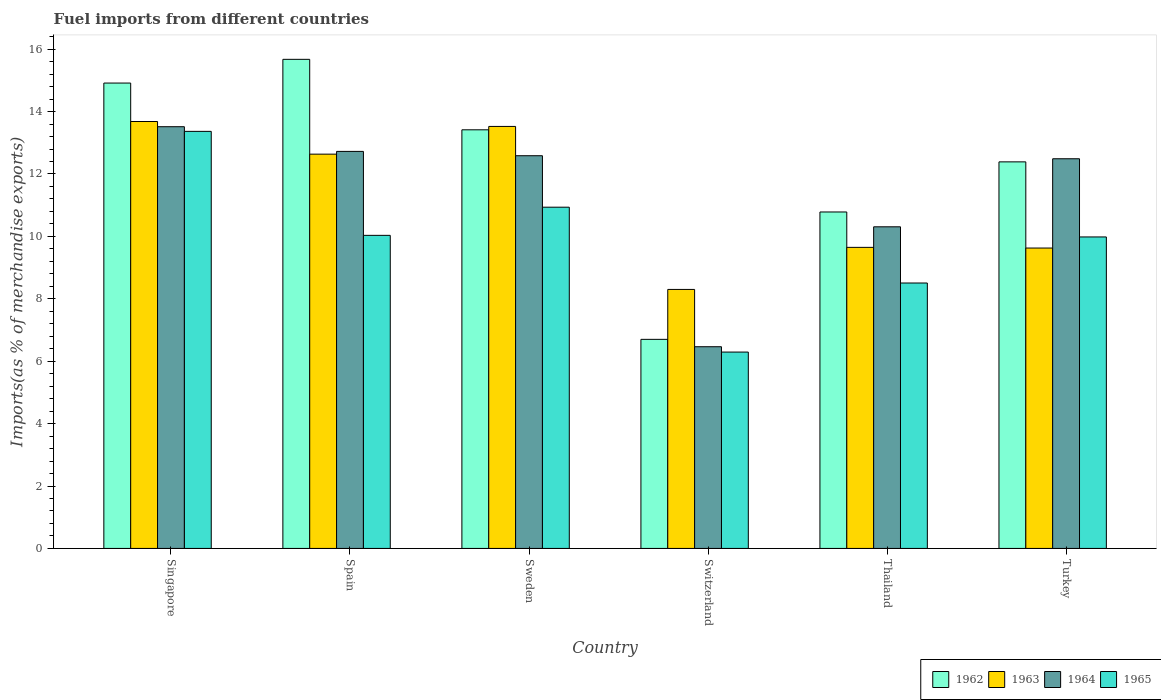How many different coloured bars are there?
Give a very brief answer. 4. Are the number of bars on each tick of the X-axis equal?
Give a very brief answer. Yes. How many bars are there on the 2nd tick from the left?
Provide a succinct answer. 4. What is the percentage of imports to different countries in 1962 in Switzerland?
Offer a terse response. 6.7. Across all countries, what is the maximum percentage of imports to different countries in 1965?
Your answer should be compact. 13.37. Across all countries, what is the minimum percentage of imports to different countries in 1965?
Ensure brevity in your answer.  6.29. In which country was the percentage of imports to different countries in 1962 maximum?
Ensure brevity in your answer.  Spain. In which country was the percentage of imports to different countries in 1962 minimum?
Provide a succinct answer. Switzerland. What is the total percentage of imports to different countries in 1964 in the graph?
Your response must be concise. 68.08. What is the difference between the percentage of imports to different countries in 1963 in Thailand and that in Turkey?
Provide a short and direct response. 0.02. What is the difference between the percentage of imports to different countries in 1964 in Turkey and the percentage of imports to different countries in 1963 in Switzerland?
Offer a very short reply. 4.19. What is the average percentage of imports to different countries in 1962 per country?
Make the answer very short. 12.31. What is the difference between the percentage of imports to different countries of/in 1963 and percentage of imports to different countries of/in 1964 in Singapore?
Give a very brief answer. 0.17. What is the ratio of the percentage of imports to different countries in 1965 in Singapore to that in Thailand?
Keep it short and to the point. 1.57. Is the percentage of imports to different countries in 1965 in Spain less than that in Sweden?
Provide a succinct answer. Yes. What is the difference between the highest and the second highest percentage of imports to different countries in 1963?
Your response must be concise. 0.89. What is the difference between the highest and the lowest percentage of imports to different countries in 1964?
Your answer should be very brief. 7.05. In how many countries, is the percentage of imports to different countries in 1963 greater than the average percentage of imports to different countries in 1963 taken over all countries?
Your response must be concise. 3. What does the 3rd bar from the left in Singapore represents?
Make the answer very short. 1964. What does the 2nd bar from the right in Switzerland represents?
Your response must be concise. 1964. Where does the legend appear in the graph?
Give a very brief answer. Bottom right. How many legend labels are there?
Make the answer very short. 4. How are the legend labels stacked?
Make the answer very short. Horizontal. What is the title of the graph?
Keep it short and to the point. Fuel imports from different countries. Does "2002" appear as one of the legend labels in the graph?
Provide a succinct answer. No. What is the label or title of the Y-axis?
Your answer should be compact. Imports(as % of merchandise exports). What is the Imports(as % of merchandise exports) in 1962 in Singapore?
Offer a terse response. 14.91. What is the Imports(as % of merchandise exports) in 1963 in Singapore?
Keep it short and to the point. 13.68. What is the Imports(as % of merchandise exports) in 1964 in Singapore?
Ensure brevity in your answer.  13.51. What is the Imports(as % of merchandise exports) in 1965 in Singapore?
Your answer should be very brief. 13.37. What is the Imports(as % of merchandise exports) of 1962 in Spain?
Make the answer very short. 15.67. What is the Imports(as % of merchandise exports) of 1963 in Spain?
Provide a short and direct response. 12.64. What is the Imports(as % of merchandise exports) of 1964 in Spain?
Make the answer very short. 12.72. What is the Imports(as % of merchandise exports) in 1965 in Spain?
Your answer should be very brief. 10.03. What is the Imports(as % of merchandise exports) in 1962 in Sweden?
Your response must be concise. 13.42. What is the Imports(as % of merchandise exports) of 1963 in Sweden?
Keep it short and to the point. 13.52. What is the Imports(as % of merchandise exports) in 1964 in Sweden?
Provide a succinct answer. 12.58. What is the Imports(as % of merchandise exports) in 1965 in Sweden?
Your response must be concise. 10.93. What is the Imports(as % of merchandise exports) of 1962 in Switzerland?
Make the answer very short. 6.7. What is the Imports(as % of merchandise exports) of 1963 in Switzerland?
Provide a short and direct response. 8.3. What is the Imports(as % of merchandise exports) in 1964 in Switzerland?
Offer a terse response. 6.46. What is the Imports(as % of merchandise exports) in 1965 in Switzerland?
Offer a very short reply. 6.29. What is the Imports(as % of merchandise exports) in 1962 in Thailand?
Keep it short and to the point. 10.78. What is the Imports(as % of merchandise exports) in 1963 in Thailand?
Make the answer very short. 9.65. What is the Imports(as % of merchandise exports) of 1964 in Thailand?
Offer a very short reply. 10.31. What is the Imports(as % of merchandise exports) in 1965 in Thailand?
Ensure brevity in your answer.  8.51. What is the Imports(as % of merchandise exports) of 1962 in Turkey?
Provide a short and direct response. 12.39. What is the Imports(as % of merchandise exports) of 1963 in Turkey?
Provide a short and direct response. 9.63. What is the Imports(as % of merchandise exports) of 1964 in Turkey?
Your answer should be compact. 12.49. What is the Imports(as % of merchandise exports) in 1965 in Turkey?
Offer a terse response. 9.98. Across all countries, what is the maximum Imports(as % of merchandise exports) in 1962?
Offer a very short reply. 15.67. Across all countries, what is the maximum Imports(as % of merchandise exports) in 1963?
Keep it short and to the point. 13.68. Across all countries, what is the maximum Imports(as % of merchandise exports) in 1964?
Keep it short and to the point. 13.51. Across all countries, what is the maximum Imports(as % of merchandise exports) in 1965?
Ensure brevity in your answer.  13.37. Across all countries, what is the minimum Imports(as % of merchandise exports) of 1962?
Make the answer very short. 6.7. Across all countries, what is the minimum Imports(as % of merchandise exports) in 1963?
Your answer should be very brief. 8.3. Across all countries, what is the minimum Imports(as % of merchandise exports) of 1964?
Give a very brief answer. 6.46. Across all countries, what is the minimum Imports(as % of merchandise exports) of 1965?
Your response must be concise. 6.29. What is the total Imports(as % of merchandise exports) in 1962 in the graph?
Your response must be concise. 73.87. What is the total Imports(as % of merchandise exports) in 1963 in the graph?
Your response must be concise. 67.41. What is the total Imports(as % of merchandise exports) of 1964 in the graph?
Provide a short and direct response. 68.08. What is the total Imports(as % of merchandise exports) in 1965 in the graph?
Your response must be concise. 59.11. What is the difference between the Imports(as % of merchandise exports) in 1962 in Singapore and that in Spain?
Provide a short and direct response. -0.76. What is the difference between the Imports(as % of merchandise exports) of 1963 in Singapore and that in Spain?
Offer a terse response. 1.05. What is the difference between the Imports(as % of merchandise exports) of 1964 in Singapore and that in Spain?
Give a very brief answer. 0.79. What is the difference between the Imports(as % of merchandise exports) of 1965 in Singapore and that in Spain?
Provide a succinct answer. 3.33. What is the difference between the Imports(as % of merchandise exports) in 1962 in Singapore and that in Sweden?
Offer a terse response. 1.5. What is the difference between the Imports(as % of merchandise exports) of 1963 in Singapore and that in Sweden?
Your response must be concise. 0.16. What is the difference between the Imports(as % of merchandise exports) in 1964 in Singapore and that in Sweden?
Ensure brevity in your answer.  0.93. What is the difference between the Imports(as % of merchandise exports) of 1965 in Singapore and that in Sweden?
Give a very brief answer. 2.43. What is the difference between the Imports(as % of merchandise exports) of 1962 in Singapore and that in Switzerland?
Your answer should be very brief. 8.21. What is the difference between the Imports(as % of merchandise exports) in 1963 in Singapore and that in Switzerland?
Make the answer very short. 5.38. What is the difference between the Imports(as % of merchandise exports) in 1964 in Singapore and that in Switzerland?
Your response must be concise. 7.05. What is the difference between the Imports(as % of merchandise exports) in 1965 in Singapore and that in Switzerland?
Give a very brief answer. 7.07. What is the difference between the Imports(as % of merchandise exports) in 1962 in Singapore and that in Thailand?
Give a very brief answer. 4.13. What is the difference between the Imports(as % of merchandise exports) of 1963 in Singapore and that in Thailand?
Provide a succinct answer. 4.03. What is the difference between the Imports(as % of merchandise exports) of 1964 in Singapore and that in Thailand?
Provide a succinct answer. 3.21. What is the difference between the Imports(as % of merchandise exports) of 1965 in Singapore and that in Thailand?
Make the answer very short. 4.86. What is the difference between the Imports(as % of merchandise exports) in 1962 in Singapore and that in Turkey?
Offer a terse response. 2.53. What is the difference between the Imports(as % of merchandise exports) of 1963 in Singapore and that in Turkey?
Offer a terse response. 4.05. What is the difference between the Imports(as % of merchandise exports) of 1964 in Singapore and that in Turkey?
Provide a succinct answer. 1.03. What is the difference between the Imports(as % of merchandise exports) of 1965 in Singapore and that in Turkey?
Keep it short and to the point. 3.38. What is the difference between the Imports(as % of merchandise exports) in 1962 in Spain and that in Sweden?
Offer a terse response. 2.26. What is the difference between the Imports(as % of merchandise exports) of 1963 in Spain and that in Sweden?
Provide a succinct answer. -0.89. What is the difference between the Imports(as % of merchandise exports) of 1964 in Spain and that in Sweden?
Your answer should be compact. 0.14. What is the difference between the Imports(as % of merchandise exports) of 1965 in Spain and that in Sweden?
Make the answer very short. -0.9. What is the difference between the Imports(as % of merchandise exports) in 1962 in Spain and that in Switzerland?
Make the answer very short. 8.97. What is the difference between the Imports(as % of merchandise exports) in 1963 in Spain and that in Switzerland?
Offer a terse response. 4.34. What is the difference between the Imports(as % of merchandise exports) of 1964 in Spain and that in Switzerland?
Provide a succinct answer. 6.26. What is the difference between the Imports(as % of merchandise exports) of 1965 in Spain and that in Switzerland?
Ensure brevity in your answer.  3.74. What is the difference between the Imports(as % of merchandise exports) of 1962 in Spain and that in Thailand?
Make the answer very short. 4.89. What is the difference between the Imports(as % of merchandise exports) of 1963 in Spain and that in Thailand?
Your answer should be compact. 2.99. What is the difference between the Imports(as % of merchandise exports) in 1964 in Spain and that in Thailand?
Provide a succinct answer. 2.42. What is the difference between the Imports(as % of merchandise exports) of 1965 in Spain and that in Thailand?
Give a very brief answer. 1.53. What is the difference between the Imports(as % of merchandise exports) in 1962 in Spain and that in Turkey?
Ensure brevity in your answer.  3.29. What is the difference between the Imports(as % of merchandise exports) in 1963 in Spain and that in Turkey?
Your answer should be compact. 3.01. What is the difference between the Imports(as % of merchandise exports) in 1964 in Spain and that in Turkey?
Offer a terse response. 0.24. What is the difference between the Imports(as % of merchandise exports) of 1965 in Spain and that in Turkey?
Ensure brevity in your answer.  0.05. What is the difference between the Imports(as % of merchandise exports) of 1962 in Sweden and that in Switzerland?
Provide a short and direct response. 6.72. What is the difference between the Imports(as % of merchandise exports) of 1963 in Sweden and that in Switzerland?
Ensure brevity in your answer.  5.22. What is the difference between the Imports(as % of merchandise exports) of 1964 in Sweden and that in Switzerland?
Offer a very short reply. 6.12. What is the difference between the Imports(as % of merchandise exports) in 1965 in Sweden and that in Switzerland?
Keep it short and to the point. 4.64. What is the difference between the Imports(as % of merchandise exports) in 1962 in Sweden and that in Thailand?
Your answer should be very brief. 2.63. What is the difference between the Imports(as % of merchandise exports) in 1963 in Sweden and that in Thailand?
Your response must be concise. 3.88. What is the difference between the Imports(as % of merchandise exports) in 1964 in Sweden and that in Thailand?
Make the answer very short. 2.28. What is the difference between the Imports(as % of merchandise exports) in 1965 in Sweden and that in Thailand?
Keep it short and to the point. 2.43. What is the difference between the Imports(as % of merchandise exports) of 1962 in Sweden and that in Turkey?
Give a very brief answer. 1.03. What is the difference between the Imports(as % of merchandise exports) of 1963 in Sweden and that in Turkey?
Your answer should be compact. 3.9. What is the difference between the Imports(as % of merchandise exports) of 1964 in Sweden and that in Turkey?
Give a very brief answer. 0.1. What is the difference between the Imports(as % of merchandise exports) of 1965 in Sweden and that in Turkey?
Make the answer very short. 0.95. What is the difference between the Imports(as % of merchandise exports) of 1962 in Switzerland and that in Thailand?
Keep it short and to the point. -4.08. What is the difference between the Imports(as % of merchandise exports) in 1963 in Switzerland and that in Thailand?
Give a very brief answer. -1.35. What is the difference between the Imports(as % of merchandise exports) in 1964 in Switzerland and that in Thailand?
Your answer should be compact. -3.84. What is the difference between the Imports(as % of merchandise exports) of 1965 in Switzerland and that in Thailand?
Keep it short and to the point. -2.21. What is the difference between the Imports(as % of merchandise exports) in 1962 in Switzerland and that in Turkey?
Your answer should be very brief. -5.69. What is the difference between the Imports(as % of merchandise exports) of 1963 in Switzerland and that in Turkey?
Your answer should be very brief. -1.33. What is the difference between the Imports(as % of merchandise exports) of 1964 in Switzerland and that in Turkey?
Your response must be concise. -6.02. What is the difference between the Imports(as % of merchandise exports) in 1965 in Switzerland and that in Turkey?
Offer a very short reply. -3.69. What is the difference between the Imports(as % of merchandise exports) in 1962 in Thailand and that in Turkey?
Give a very brief answer. -1.61. What is the difference between the Imports(as % of merchandise exports) in 1963 in Thailand and that in Turkey?
Keep it short and to the point. 0.02. What is the difference between the Imports(as % of merchandise exports) of 1964 in Thailand and that in Turkey?
Your answer should be very brief. -2.18. What is the difference between the Imports(as % of merchandise exports) in 1965 in Thailand and that in Turkey?
Provide a succinct answer. -1.48. What is the difference between the Imports(as % of merchandise exports) in 1962 in Singapore and the Imports(as % of merchandise exports) in 1963 in Spain?
Make the answer very short. 2.28. What is the difference between the Imports(as % of merchandise exports) in 1962 in Singapore and the Imports(as % of merchandise exports) in 1964 in Spain?
Your answer should be compact. 2.19. What is the difference between the Imports(as % of merchandise exports) in 1962 in Singapore and the Imports(as % of merchandise exports) in 1965 in Spain?
Make the answer very short. 4.88. What is the difference between the Imports(as % of merchandise exports) in 1963 in Singapore and the Imports(as % of merchandise exports) in 1964 in Spain?
Ensure brevity in your answer.  0.96. What is the difference between the Imports(as % of merchandise exports) in 1963 in Singapore and the Imports(as % of merchandise exports) in 1965 in Spain?
Your response must be concise. 3.65. What is the difference between the Imports(as % of merchandise exports) of 1964 in Singapore and the Imports(as % of merchandise exports) of 1965 in Spain?
Your response must be concise. 3.48. What is the difference between the Imports(as % of merchandise exports) of 1962 in Singapore and the Imports(as % of merchandise exports) of 1963 in Sweden?
Your answer should be compact. 1.39. What is the difference between the Imports(as % of merchandise exports) of 1962 in Singapore and the Imports(as % of merchandise exports) of 1964 in Sweden?
Your response must be concise. 2.33. What is the difference between the Imports(as % of merchandise exports) in 1962 in Singapore and the Imports(as % of merchandise exports) in 1965 in Sweden?
Your answer should be compact. 3.98. What is the difference between the Imports(as % of merchandise exports) of 1963 in Singapore and the Imports(as % of merchandise exports) of 1964 in Sweden?
Your response must be concise. 1.1. What is the difference between the Imports(as % of merchandise exports) of 1963 in Singapore and the Imports(as % of merchandise exports) of 1965 in Sweden?
Your answer should be compact. 2.75. What is the difference between the Imports(as % of merchandise exports) in 1964 in Singapore and the Imports(as % of merchandise exports) in 1965 in Sweden?
Provide a short and direct response. 2.58. What is the difference between the Imports(as % of merchandise exports) in 1962 in Singapore and the Imports(as % of merchandise exports) in 1963 in Switzerland?
Make the answer very short. 6.61. What is the difference between the Imports(as % of merchandise exports) of 1962 in Singapore and the Imports(as % of merchandise exports) of 1964 in Switzerland?
Provide a succinct answer. 8.45. What is the difference between the Imports(as % of merchandise exports) of 1962 in Singapore and the Imports(as % of merchandise exports) of 1965 in Switzerland?
Provide a short and direct response. 8.62. What is the difference between the Imports(as % of merchandise exports) of 1963 in Singapore and the Imports(as % of merchandise exports) of 1964 in Switzerland?
Give a very brief answer. 7.22. What is the difference between the Imports(as % of merchandise exports) of 1963 in Singapore and the Imports(as % of merchandise exports) of 1965 in Switzerland?
Ensure brevity in your answer.  7.39. What is the difference between the Imports(as % of merchandise exports) of 1964 in Singapore and the Imports(as % of merchandise exports) of 1965 in Switzerland?
Offer a terse response. 7.22. What is the difference between the Imports(as % of merchandise exports) in 1962 in Singapore and the Imports(as % of merchandise exports) in 1963 in Thailand?
Give a very brief answer. 5.27. What is the difference between the Imports(as % of merchandise exports) of 1962 in Singapore and the Imports(as % of merchandise exports) of 1964 in Thailand?
Make the answer very short. 4.61. What is the difference between the Imports(as % of merchandise exports) in 1962 in Singapore and the Imports(as % of merchandise exports) in 1965 in Thailand?
Keep it short and to the point. 6.41. What is the difference between the Imports(as % of merchandise exports) in 1963 in Singapore and the Imports(as % of merchandise exports) in 1964 in Thailand?
Make the answer very short. 3.37. What is the difference between the Imports(as % of merchandise exports) in 1963 in Singapore and the Imports(as % of merchandise exports) in 1965 in Thailand?
Your answer should be very brief. 5.18. What is the difference between the Imports(as % of merchandise exports) of 1964 in Singapore and the Imports(as % of merchandise exports) of 1965 in Thailand?
Your answer should be compact. 5.01. What is the difference between the Imports(as % of merchandise exports) of 1962 in Singapore and the Imports(as % of merchandise exports) of 1963 in Turkey?
Give a very brief answer. 5.29. What is the difference between the Imports(as % of merchandise exports) of 1962 in Singapore and the Imports(as % of merchandise exports) of 1964 in Turkey?
Your answer should be very brief. 2.43. What is the difference between the Imports(as % of merchandise exports) of 1962 in Singapore and the Imports(as % of merchandise exports) of 1965 in Turkey?
Your answer should be very brief. 4.93. What is the difference between the Imports(as % of merchandise exports) of 1963 in Singapore and the Imports(as % of merchandise exports) of 1964 in Turkey?
Your response must be concise. 1.19. What is the difference between the Imports(as % of merchandise exports) in 1963 in Singapore and the Imports(as % of merchandise exports) in 1965 in Turkey?
Your answer should be very brief. 3.7. What is the difference between the Imports(as % of merchandise exports) of 1964 in Singapore and the Imports(as % of merchandise exports) of 1965 in Turkey?
Make the answer very short. 3.53. What is the difference between the Imports(as % of merchandise exports) in 1962 in Spain and the Imports(as % of merchandise exports) in 1963 in Sweden?
Offer a very short reply. 2.15. What is the difference between the Imports(as % of merchandise exports) in 1962 in Spain and the Imports(as % of merchandise exports) in 1964 in Sweden?
Your answer should be very brief. 3.09. What is the difference between the Imports(as % of merchandise exports) of 1962 in Spain and the Imports(as % of merchandise exports) of 1965 in Sweden?
Give a very brief answer. 4.74. What is the difference between the Imports(as % of merchandise exports) in 1963 in Spain and the Imports(as % of merchandise exports) in 1964 in Sweden?
Your response must be concise. 0.05. What is the difference between the Imports(as % of merchandise exports) in 1963 in Spain and the Imports(as % of merchandise exports) in 1965 in Sweden?
Provide a succinct answer. 1.7. What is the difference between the Imports(as % of merchandise exports) of 1964 in Spain and the Imports(as % of merchandise exports) of 1965 in Sweden?
Your answer should be compact. 1.79. What is the difference between the Imports(as % of merchandise exports) in 1962 in Spain and the Imports(as % of merchandise exports) in 1963 in Switzerland?
Your answer should be compact. 7.37. What is the difference between the Imports(as % of merchandise exports) in 1962 in Spain and the Imports(as % of merchandise exports) in 1964 in Switzerland?
Your answer should be very brief. 9.21. What is the difference between the Imports(as % of merchandise exports) of 1962 in Spain and the Imports(as % of merchandise exports) of 1965 in Switzerland?
Ensure brevity in your answer.  9.38. What is the difference between the Imports(as % of merchandise exports) of 1963 in Spain and the Imports(as % of merchandise exports) of 1964 in Switzerland?
Provide a short and direct response. 6.17. What is the difference between the Imports(as % of merchandise exports) of 1963 in Spain and the Imports(as % of merchandise exports) of 1965 in Switzerland?
Your response must be concise. 6.34. What is the difference between the Imports(as % of merchandise exports) in 1964 in Spain and the Imports(as % of merchandise exports) in 1965 in Switzerland?
Offer a very short reply. 6.43. What is the difference between the Imports(as % of merchandise exports) in 1962 in Spain and the Imports(as % of merchandise exports) in 1963 in Thailand?
Make the answer very short. 6.03. What is the difference between the Imports(as % of merchandise exports) in 1962 in Spain and the Imports(as % of merchandise exports) in 1964 in Thailand?
Give a very brief answer. 5.37. What is the difference between the Imports(as % of merchandise exports) in 1962 in Spain and the Imports(as % of merchandise exports) in 1965 in Thailand?
Provide a short and direct response. 7.17. What is the difference between the Imports(as % of merchandise exports) of 1963 in Spain and the Imports(as % of merchandise exports) of 1964 in Thailand?
Give a very brief answer. 2.33. What is the difference between the Imports(as % of merchandise exports) in 1963 in Spain and the Imports(as % of merchandise exports) in 1965 in Thailand?
Ensure brevity in your answer.  4.13. What is the difference between the Imports(as % of merchandise exports) of 1964 in Spain and the Imports(as % of merchandise exports) of 1965 in Thailand?
Ensure brevity in your answer.  4.22. What is the difference between the Imports(as % of merchandise exports) of 1962 in Spain and the Imports(as % of merchandise exports) of 1963 in Turkey?
Offer a terse response. 6.05. What is the difference between the Imports(as % of merchandise exports) of 1962 in Spain and the Imports(as % of merchandise exports) of 1964 in Turkey?
Keep it short and to the point. 3.19. What is the difference between the Imports(as % of merchandise exports) in 1962 in Spain and the Imports(as % of merchandise exports) in 1965 in Turkey?
Your response must be concise. 5.69. What is the difference between the Imports(as % of merchandise exports) of 1963 in Spain and the Imports(as % of merchandise exports) of 1964 in Turkey?
Provide a succinct answer. 0.15. What is the difference between the Imports(as % of merchandise exports) in 1963 in Spain and the Imports(as % of merchandise exports) in 1965 in Turkey?
Your answer should be compact. 2.65. What is the difference between the Imports(as % of merchandise exports) in 1964 in Spain and the Imports(as % of merchandise exports) in 1965 in Turkey?
Make the answer very short. 2.74. What is the difference between the Imports(as % of merchandise exports) of 1962 in Sweden and the Imports(as % of merchandise exports) of 1963 in Switzerland?
Provide a succinct answer. 5.12. What is the difference between the Imports(as % of merchandise exports) of 1962 in Sweden and the Imports(as % of merchandise exports) of 1964 in Switzerland?
Make the answer very short. 6.95. What is the difference between the Imports(as % of merchandise exports) of 1962 in Sweden and the Imports(as % of merchandise exports) of 1965 in Switzerland?
Make the answer very short. 7.12. What is the difference between the Imports(as % of merchandise exports) of 1963 in Sweden and the Imports(as % of merchandise exports) of 1964 in Switzerland?
Give a very brief answer. 7.06. What is the difference between the Imports(as % of merchandise exports) in 1963 in Sweden and the Imports(as % of merchandise exports) in 1965 in Switzerland?
Give a very brief answer. 7.23. What is the difference between the Imports(as % of merchandise exports) in 1964 in Sweden and the Imports(as % of merchandise exports) in 1965 in Switzerland?
Provide a short and direct response. 6.29. What is the difference between the Imports(as % of merchandise exports) in 1962 in Sweden and the Imports(as % of merchandise exports) in 1963 in Thailand?
Ensure brevity in your answer.  3.77. What is the difference between the Imports(as % of merchandise exports) of 1962 in Sweden and the Imports(as % of merchandise exports) of 1964 in Thailand?
Offer a terse response. 3.11. What is the difference between the Imports(as % of merchandise exports) of 1962 in Sweden and the Imports(as % of merchandise exports) of 1965 in Thailand?
Provide a succinct answer. 4.91. What is the difference between the Imports(as % of merchandise exports) of 1963 in Sweden and the Imports(as % of merchandise exports) of 1964 in Thailand?
Offer a terse response. 3.22. What is the difference between the Imports(as % of merchandise exports) in 1963 in Sweden and the Imports(as % of merchandise exports) in 1965 in Thailand?
Give a very brief answer. 5.02. What is the difference between the Imports(as % of merchandise exports) of 1964 in Sweden and the Imports(as % of merchandise exports) of 1965 in Thailand?
Give a very brief answer. 4.08. What is the difference between the Imports(as % of merchandise exports) of 1962 in Sweden and the Imports(as % of merchandise exports) of 1963 in Turkey?
Make the answer very short. 3.79. What is the difference between the Imports(as % of merchandise exports) in 1962 in Sweden and the Imports(as % of merchandise exports) in 1964 in Turkey?
Offer a very short reply. 0.93. What is the difference between the Imports(as % of merchandise exports) in 1962 in Sweden and the Imports(as % of merchandise exports) in 1965 in Turkey?
Provide a succinct answer. 3.43. What is the difference between the Imports(as % of merchandise exports) of 1963 in Sweden and the Imports(as % of merchandise exports) of 1964 in Turkey?
Ensure brevity in your answer.  1.04. What is the difference between the Imports(as % of merchandise exports) in 1963 in Sweden and the Imports(as % of merchandise exports) in 1965 in Turkey?
Your answer should be very brief. 3.54. What is the difference between the Imports(as % of merchandise exports) in 1964 in Sweden and the Imports(as % of merchandise exports) in 1965 in Turkey?
Your answer should be very brief. 2.6. What is the difference between the Imports(as % of merchandise exports) of 1962 in Switzerland and the Imports(as % of merchandise exports) of 1963 in Thailand?
Your response must be concise. -2.95. What is the difference between the Imports(as % of merchandise exports) in 1962 in Switzerland and the Imports(as % of merchandise exports) in 1964 in Thailand?
Keep it short and to the point. -3.61. What is the difference between the Imports(as % of merchandise exports) in 1962 in Switzerland and the Imports(as % of merchandise exports) in 1965 in Thailand?
Ensure brevity in your answer.  -1.81. What is the difference between the Imports(as % of merchandise exports) of 1963 in Switzerland and the Imports(as % of merchandise exports) of 1964 in Thailand?
Keep it short and to the point. -2.01. What is the difference between the Imports(as % of merchandise exports) of 1963 in Switzerland and the Imports(as % of merchandise exports) of 1965 in Thailand?
Your response must be concise. -0.21. What is the difference between the Imports(as % of merchandise exports) in 1964 in Switzerland and the Imports(as % of merchandise exports) in 1965 in Thailand?
Your response must be concise. -2.04. What is the difference between the Imports(as % of merchandise exports) of 1962 in Switzerland and the Imports(as % of merchandise exports) of 1963 in Turkey?
Make the answer very short. -2.93. What is the difference between the Imports(as % of merchandise exports) in 1962 in Switzerland and the Imports(as % of merchandise exports) in 1964 in Turkey?
Ensure brevity in your answer.  -5.79. What is the difference between the Imports(as % of merchandise exports) in 1962 in Switzerland and the Imports(as % of merchandise exports) in 1965 in Turkey?
Provide a short and direct response. -3.28. What is the difference between the Imports(as % of merchandise exports) of 1963 in Switzerland and the Imports(as % of merchandise exports) of 1964 in Turkey?
Provide a succinct answer. -4.19. What is the difference between the Imports(as % of merchandise exports) in 1963 in Switzerland and the Imports(as % of merchandise exports) in 1965 in Turkey?
Offer a terse response. -1.68. What is the difference between the Imports(as % of merchandise exports) of 1964 in Switzerland and the Imports(as % of merchandise exports) of 1965 in Turkey?
Give a very brief answer. -3.52. What is the difference between the Imports(as % of merchandise exports) of 1962 in Thailand and the Imports(as % of merchandise exports) of 1963 in Turkey?
Offer a terse response. 1.16. What is the difference between the Imports(as % of merchandise exports) of 1962 in Thailand and the Imports(as % of merchandise exports) of 1964 in Turkey?
Ensure brevity in your answer.  -1.71. What is the difference between the Imports(as % of merchandise exports) in 1963 in Thailand and the Imports(as % of merchandise exports) in 1964 in Turkey?
Ensure brevity in your answer.  -2.84. What is the difference between the Imports(as % of merchandise exports) of 1963 in Thailand and the Imports(as % of merchandise exports) of 1965 in Turkey?
Make the answer very short. -0.33. What is the difference between the Imports(as % of merchandise exports) in 1964 in Thailand and the Imports(as % of merchandise exports) in 1965 in Turkey?
Offer a very short reply. 0.32. What is the average Imports(as % of merchandise exports) in 1962 per country?
Provide a succinct answer. 12.31. What is the average Imports(as % of merchandise exports) of 1963 per country?
Offer a terse response. 11.24. What is the average Imports(as % of merchandise exports) of 1964 per country?
Keep it short and to the point. 11.35. What is the average Imports(as % of merchandise exports) of 1965 per country?
Your response must be concise. 9.85. What is the difference between the Imports(as % of merchandise exports) of 1962 and Imports(as % of merchandise exports) of 1963 in Singapore?
Your answer should be compact. 1.23. What is the difference between the Imports(as % of merchandise exports) in 1962 and Imports(as % of merchandise exports) in 1964 in Singapore?
Keep it short and to the point. 1.4. What is the difference between the Imports(as % of merchandise exports) of 1962 and Imports(as % of merchandise exports) of 1965 in Singapore?
Make the answer very short. 1.55. What is the difference between the Imports(as % of merchandise exports) in 1963 and Imports(as % of merchandise exports) in 1964 in Singapore?
Make the answer very short. 0.17. What is the difference between the Imports(as % of merchandise exports) of 1963 and Imports(as % of merchandise exports) of 1965 in Singapore?
Your answer should be compact. 0.32. What is the difference between the Imports(as % of merchandise exports) of 1964 and Imports(as % of merchandise exports) of 1965 in Singapore?
Your answer should be very brief. 0.15. What is the difference between the Imports(as % of merchandise exports) of 1962 and Imports(as % of merchandise exports) of 1963 in Spain?
Make the answer very short. 3.04. What is the difference between the Imports(as % of merchandise exports) of 1962 and Imports(as % of merchandise exports) of 1964 in Spain?
Your answer should be compact. 2.95. What is the difference between the Imports(as % of merchandise exports) in 1962 and Imports(as % of merchandise exports) in 1965 in Spain?
Offer a terse response. 5.64. What is the difference between the Imports(as % of merchandise exports) in 1963 and Imports(as % of merchandise exports) in 1964 in Spain?
Offer a very short reply. -0.09. What is the difference between the Imports(as % of merchandise exports) in 1963 and Imports(as % of merchandise exports) in 1965 in Spain?
Provide a short and direct response. 2.6. What is the difference between the Imports(as % of merchandise exports) in 1964 and Imports(as % of merchandise exports) in 1965 in Spain?
Keep it short and to the point. 2.69. What is the difference between the Imports(as % of merchandise exports) of 1962 and Imports(as % of merchandise exports) of 1963 in Sweden?
Your answer should be very brief. -0.11. What is the difference between the Imports(as % of merchandise exports) in 1962 and Imports(as % of merchandise exports) in 1964 in Sweden?
Offer a very short reply. 0.83. What is the difference between the Imports(as % of merchandise exports) of 1962 and Imports(as % of merchandise exports) of 1965 in Sweden?
Your response must be concise. 2.48. What is the difference between the Imports(as % of merchandise exports) of 1963 and Imports(as % of merchandise exports) of 1964 in Sweden?
Your response must be concise. 0.94. What is the difference between the Imports(as % of merchandise exports) of 1963 and Imports(as % of merchandise exports) of 1965 in Sweden?
Make the answer very short. 2.59. What is the difference between the Imports(as % of merchandise exports) of 1964 and Imports(as % of merchandise exports) of 1965 in Sweden?
Your answer should be compact. 1.65. What is the difference between the Imports(as % of merchandise exports) of 1962 and Imports(as % of merchandise exports) of 1963 in Switzerland?
Give a very brief answer. -1.6. What is the difference between the Imports(as % of merchandise exports) in 1962 and Imports(as % of merchandise exports) in 1964 in Switzerland?
Your response must be concise. 0.24. What is the difference between the Imports(as % of merchandise exports) of 1962 and Imports(as % of merchandise exports) of 1965 in Switzerland?
Offer a terse response. 0.41. What is the difference between the Imports(as % of merchandise exports) of 1963 and Imports(as % of merchandise exports) of 1964 in Switzerland?
Make the answer very short. 1.84. What is the difference between the Imports(as % of merchandise exports) of 1963 and Imports(as % of merchandise exports) of 1965 in Switzerland?
Provide a short and direct response. 2.01. What is the difference between the Imports(as % of merchandise exports) in 1964 and Imports(as % of merchandise exports) in 1965 in Switzerland?
Offer a very short reply. 0.17. What is the difference between the Imports(as % of merchandise exports) in 1962 and Imports(as % of merchandise exports) in 1963 in Thailand?
Your answer should be compact. 1.13. What is the difference between the Imports(as % of merchandise exports) in 1962 and Imports(as % of merchandise exports) in 1964 in Thailand?
Keep it short and to the point. 0.48. What is the difference between the Imports(as % of merchandise exports) in 1962 and Imports(as % of merchandise exports) in 1965 in Thailand?
Provide a succinct answer. 2.28. What is the difference between the Imports(as % of merchandise exports) of 1963 and Imports(as % of merchandise exports) of 1964 in Thailand?
Your answer should be very brief. -0.66. What is the difference between the Imports(as % of merchandise exports) in 1963 and Imports(as % of merchandise exports) in 1965 in Thailand?
Provide a short and direct response. 1.14. What is the difference between the Imports(as % of merchandise exports) in 1964 and Imports(as % of merchandise exports) in 1965 in Thailand?
Provide a succinct answer. 1.8. What is the difference between the Imports(as % of merchandise exports) of 1962 and Imports(as % of merchandise exports) of 1963 in Turkey?
Provide a short and direct response. 2.76. What is the difference between the Imports(as % of merchandise exports) of 1962 and Imports(as % of merchandise exports) of 1964 in Turkey?
Offer a very short reply. -0.1. What is the difference between the Imports(as % of merchandise exports) in 1962 and Imports(as % of merchandise exports) in 1965 in Turkey?
Provide a succinct answer. 2.41. What is the difference between the Imports(as % of merchandise exports) in 1963 and Imports(as % of merchandise exports) in 1964 in Turkey?
Give a very brief answer. -2.86. What is the difference between the Imports(as % of merchandise exports) in 1963 and Imports(as % of merchandise exports) in 1965 in Turkey?
Offer a terse response. -0.36. What is the difference between the Imports(as % of merchandise exports) in 1964 and Imports(as % of merchandise exports) in 1965 in Turkey?
Offer a very short reply. 2.51. What is the ratio of the Imports(as % of merchandise exports) of 1962 in Singapore to that in Spain?
Offer a very short reply. 0.95. What is the ratio of the Imports(as % of merchandise exports) of 1963 in Singapore to that in Spain?
Give a very brief answer. 1.08. What is the ratio of the Imports(as % of merchandise exports) of 1964 in Singapore to that in Spain?
Provide a short and direct response. 1.06. What is the ratio of the Imports(as % of merchandise exports) of 1965 in Singapore to that in Spain?
Provide a short and direct response. 1.33. What is the ratio of the Imports(as % of merchandise exports) of 1962 in Singapore to that in Sweden?
Your response must be concise. 1.11. What is the ratio of the Imports(as % of merchandise exports) in 1963 in Singapore to that in Sweden?
Provide a short and direct response. 1.01. What is the ratio of the Imports(as % of merchandise exports) in 1964 in Singapore to that in Sweden?
Offer a terse response. 1.07. What is the ratio of the Imports(as % of merchandise exports) in 1965 in Singapore to that in Sweden?
Ensure brevity in your answer.  1.22. What is the ratio of the Imports(as % of merchandise exports) in 1962 in Singapore to that in Switzerland?
Offer a very short reply. 2.23. What is the ratio of the Imports(as % of merchandise exports) of 1963 in Singapore to that in Switzerland?
Ensure brevity in your answer.  1.65. What is the ratio of the Imports(as % of merchandise exports) in 1964 in Singapore to that in Switzerland?
Your response must be concise. 2.09. What is the ratio of the Imports(as % of merchandise exports) of 1965 in Singapore to that in Switzerland?
Keep it short and to the point. 2.12. What is the ratio of the Imports(as % of merchandise exports) of 1962 in Singapore to that in Thailand?
Offer a terse response. 1.38. What is the ratio of the Imports(as % of merchandise exports) of 1963 in Singapore to that in Thailand?
Your answer should be compact. 1.42. What is the ratio of the Imports(as % of merchandise exports) of 1964 in Singapore to that in Thailand?
Your response must be concise. 1.31. What is the ratio of the Imports(as % of merchandise exports) of 1965 in Singapore to that in Thailand?
Provide a short and direct response. 1.57. What is the ratio of the Imports(as % of merchandise exports) in 1962 in Singapore to that in Turkey?
Your response must be concise. 1.2. What is the ratio of the Imports(as % of merchandise exports) in 1963 in Singapore to that in Turkey?
Ensure brevity in your answer.  1.42. What is the ratio of the Imports(as % of merchandise exports) in 1964 in Singapore to that in Turkey?
Offer a terse response. 1.08. What is the ratio of the Imports(as % of merchandise exports) in 1965 in Singapore to that in Turkey?
Your response must be concise. 1.34. What is the ratio of the Imports(as % of merchandise exports) of 1962 in Spain to that in Sweden?
Offer a very short reply. 1.17. What is the ratio of the Imports(as % of merchandise exports) of 1963 in Spain to that in Sweden?
Your response must be concise. 0.93. What is the ratio of the Imports(as % of merchandise exports) of 1964 in Spain to that in Sweden?
Your response must be concise. 1.01. What is the ratio of the Imports(as % of merchandise exports) of 1965 in Spain to that in Sweden?
Your answer should be compact. 0.92. What is the ratio of the Imports(as % of merchandise exports) in 1962 in Spain to that in Switzerland?
Your response must be concise. 2.34. What is the ratio of the Imports(as % of merchandise exports) in 1963 in Spain to that in Switzerland?
Offer a terse response. 1.52. What is the ratio of the Imports(as % of merchandise exports) in 1964 in Spain to that in Switzerland?
Make the answer very short. 1.97. What is the ratio of the Imports(as % of merchandise exports) of 1965 in Spain to that in Switzerland?
Keep it short and to the point. 1.59. What is the ratio of the Imports(as % of merchandise exports) of 1962 in Spain to that in Thailand?
Ensure brevity in your answer.  1.45. What is the ratio of the Imports(as % of merchandise exports) in 1963 in Spain to that in Thailand?
Your response must be concise. 1.31. What is the ratio of the Imports(as % of merchandise exports) in 1964 in Spain to that in Thailand?
Provide a succinct answer. 1.23. What is the ratio of the Imports(as % of merchandise exports) in 1965 in Spain to that in Thailand?
Offer a very short reply. 1.18. What is the ratio of the Imports(as % of merchandise exports) of 1962 in Spain to that in Turkey?
Your answer should be very brief. 1.27. What is the ratio of the Imports(as % of merchandise exports) in 1963 in Spain to that in Turkey?
Ensure brevity in your answer.  1.31. What is the ratio of the Imports(as % of merchandise exports) of 1964 in Spain to that in Turkey?
Keep it short and to the point. 1.02. What is the ratio of the Imports(as % of merchandise exports) in 1962 in Sweden to that in Switzerland?
Your response must be concise. 2. What is the ratio of the Imports(as % of merchandise exports) of 1963 in Sweden to that in Switzerland?
Ensure brevity in your answer.  1.63. What is the ratio of the Imports(as % of merchandise exports) of 1964 in Sweden to that in Switzerland?
Make the answer very short. 1.95. What is the ratio of the Imports(as % of merchandise exports) of 1965 in Sweden to that in Switzerland?
Provide a short and direct response. 1.74. What is the ratio of the Imports(as % of merchandise exports) of 1962 in Sweden to that in Thailand?
Provide a short and direct response. 1.24. What is the ratio of the Imports(as % of merchandise exports) of 1963 in Sweden to that in Thailand?
Keep it short and to the point. 1.4. What is the ratio of the Imports(as % of merchandise exports) of 1964 in Sweden to that in Thailand?
Offer a terse response. 1.22. What is the ratio of the Imports(as % of merchandise exports) in 1965 in Sweden to that in Thailand?
Your answer should be very brief. 1.29. What is the ratio of the Imports(as % of merchandise exports) of 1962 in Sweden to that in Turkey?
Your answer should be very brief. 1.08. What is the ratio of the Imports(as % of merchandise exports) in 1963 in Sweden to that in Turkey?
Make the answer very short. 1.4. What is the ratio of the Imports(as % of merchandise exports) of 1964 in Sweden to that in Turkey?
Your response must be concise. 1.01. What is the ratio of the Imports(as % of merchandise exports) in 1965 in Sweden to that in Turkey?
Your response must be concise. 1.1. What is the ratio of the Imports(as % of merchandise exports) of 1962 in Switzerland to that in Thailand?
Your answer should be compact. 0.62. What is the ratio of the Imports(as % of merchandise exports) in 1963 in Switzerland to that in Thailand?
Make the answer very short. 0.86. What is the ratio of the Imports(as % of merchandise exports) in 1964 in Switzerland to that in Thailand?
Your answer should be compact. 0.63. What is the ratio of the Imports(as % of merchandise exports) of 1965 in Switzerland to that in Thailand?
Provide a succinct answer. 0.74. What is the ratio of the Imports(as % of merchandise exports) in 1962 in Switzerland to that in Turkey?
Ensure brevity in your answer.  0.54. What is the ratio of the Imports(as % of merchandise exports) in 1963 in Switzerland to that in Turkey?
Provide a short and direct response. 0.86. What is the ratio of the Imports(as % of merchandise exports) in 1964 in Switzerland to that in Turkey?
Make the answer very short. 0.52. What is the ratio of the Imports(as % of merchandise exports) of 1965 in Switzerland to that in Turkey?
Offer a very short reply. 0.63. What is the ratio of the Imports(as % of merchandise exports) of 1962 in Thailand to that in Turkey?
Your answer should be compact. 0.87. What is the ratio of the Imports(as % of merchandise exports) of 1963 in Thailand to that in Turkey?
Ensure brevity in your answer.  1. What is the ratio of the Imports(as % of merchandise exports) in 1964 in Thailand to that in Turkey?
Offer a terse response. 0.83. What is the ratio of the Imports(as % of merchandise exports) of 1965 in Thailand to that in Turkey?
Provide a short and direct response. 0.85. What is the difference between the highest and the second highest Imports(as % of merchandise exports) in 1962?
Your answer should be compact. 0.76. What is the difference between the highest and the second highest Imports(as % of merchandise exports) in 1963?
Offer a terse response. 0.16. What is the difference between the highest and the second highest Imports(as % of merchandise exports) in 1964?
Give a very brief answer. 0.79. What is the difference between the highest and the second highest Imports(as % of merchandise exports) in 1965?
Your answer should be compact. 2.43. What is the difference between the highest and the lowest Imports(as % of merchandise exports) of 1962?
Ensure brevity in your answer.  8.97. What is the difference between the highest and the lowest Imports(as % of merchandise exports) of 1963?
Offer a very short reply. 5.38. What is the difference between the highest and the lowest Imports(as % of merchandise exports) of 1964?
Provide a succinct answer. 7.05. What is the difference between the highest and the lowest Imports(as % of merchandise exports) of 1965?
Ensure brevity in your answer.  7.07. 